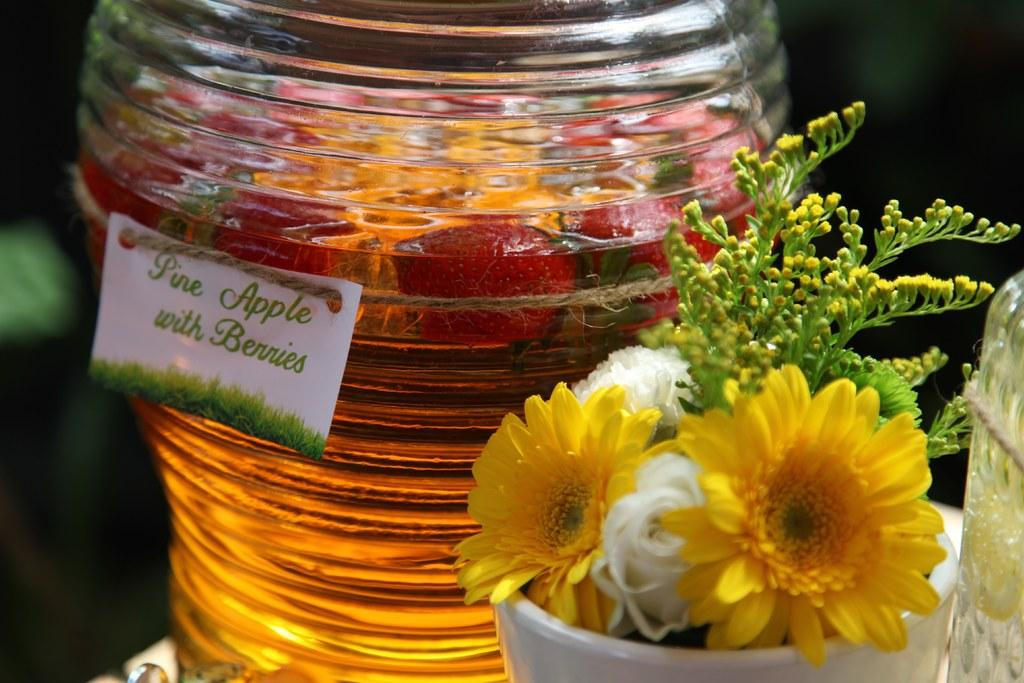What colors are the flowers in the image? The flowers in the image are yellow and white. Where are the flowers located? The flowers are in a white pot. What is in the glass jar in the image? There are strawberries in a glass jar. What color is the pot containing the flowers? The pot is white. What is the background color of the image? The background of the image is black. What is the route of the flowers in the image? There is no route present in the image, as it features flowers in a white pot, strawberries in a glass jar, and a black background. 